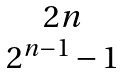Convert formula to latex. <formula><loc_0><loc_0><loc_500><loc_500>\begin{matrix} 2 n \\ 2 ^ { n - 1 } - 1 \end{matrix}</formula> 